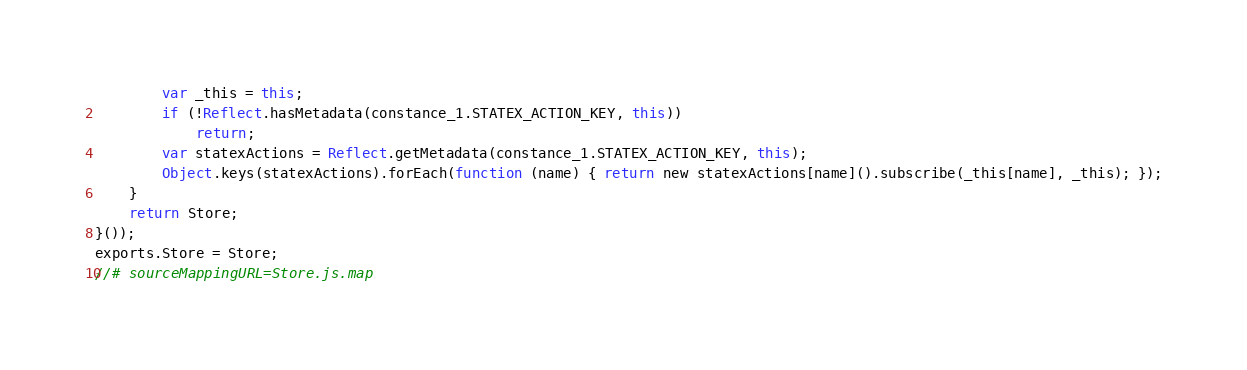<code> <loc_0><loc_0><loc_500><loc_500><_JavaScript_>        var _this = this;
        if (!Reflect.hasMetadata(constance_1.STATEX_ACTION_KEY, this))
            return;
        var statexActions = Reflect.getMetadata(constance_1.STATEX_ACTION_KEY, this);
        Object.keys(statexActions).forEach(function (name) { return new statexActions[name]().subscribe(_this[name], _this); });
    }
    return Store;
}());
exports.Store = Store;
//# sourceMappingURL=Store.js.map</code> 